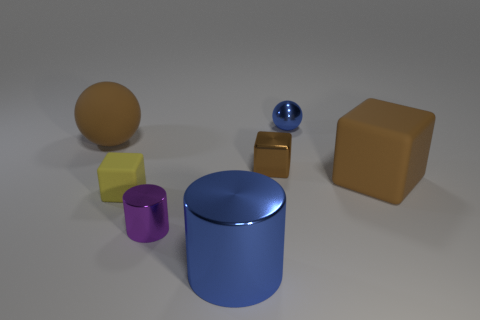What material is the cylinder that is the same color as the small sphere?
Keep it short and to the point. Metal. What number of other things are there of the same color as the large cylinder?
Offer a very short reply. 1. Is the number of small metallic cubes that are behind the blue ball less than the number of matte objects in front of the big blue metallic cylinder?
Your answer should be compact. No. There is a sphere that is the same size as the brown rubber cube; what material is it?
Make the answer very short. Rubber. How many big objects are brown matte cubes or blue metal things?
Provide a succinct answer. 2. Is there a tiny gray shiny block?
Make the answer very short. No. There is a brown object that is the same material as the tiny blue object; what size is it?
Provide a succinct answer. Small. Is the yellow cube made of the same material as the large ball?
Provide a succinct answer. Yes. How many other things are the same material as the yellow thing?
Make the answer very short. 2. What number of metallic things are both right of the tiny purple shiny cylinder and in front of the yellow cube?
Your answer should be very brief. 1. 